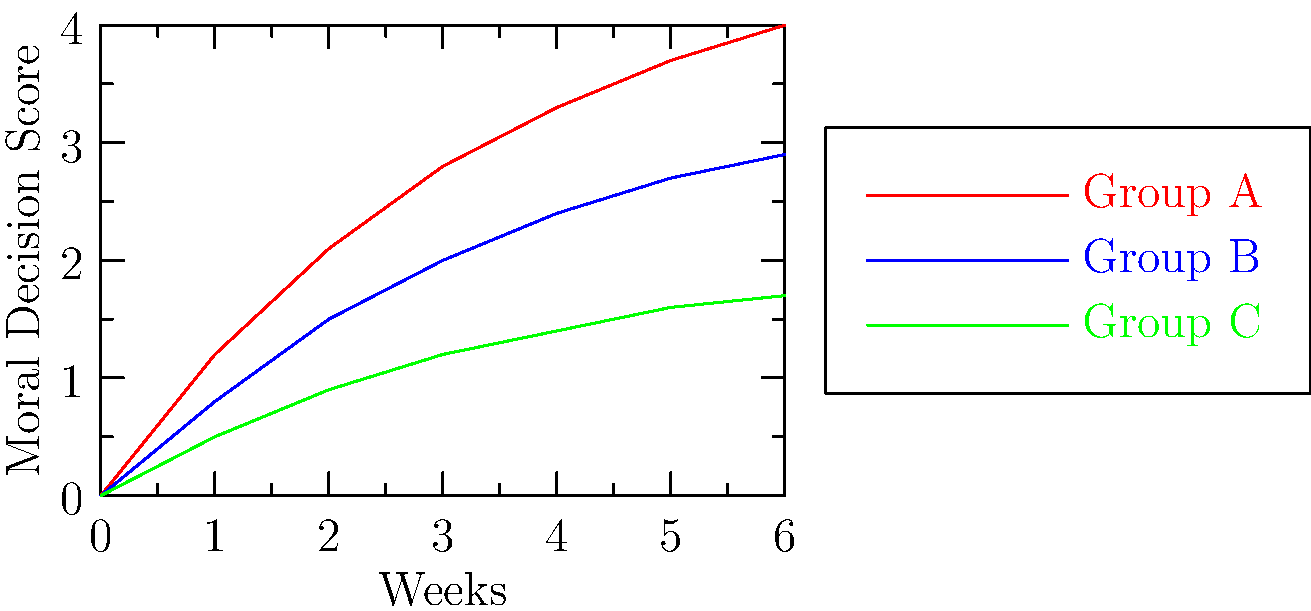A study was conducted to compare the effectiveness of three different moral education interventions in virtual environments. The graph shows the average moral decision scores for three groups over a 6-week period. Based on the data presented, which intervention appears to be the most effective in improving moral decision-making, and what is the approximate difference in scores between the most and least effective interventions at the end of the study? To answer this question, we need to analyze the graph and compare the three intervention groups:

1. Identify the groups:
   - Group A (red line)
   - Group B (blue line)
   - Group C (green line)

2. Compare the final scores at week 6:
   - Group A: approximately 4.0
   - Group B: approximately 2.9
   - Group C: approximately 1.7

3. Determine the most effective intervention:
   Group A has the highest final score, indicating it is the most effective intervention.

4. Determine the least effective intervention:
   Group C has the lowest final score, indicating it is the least effective intervention.

5. Calculate the approximate difference between the most and least effective interventions:
   Difference = Group A score - Group C score
               ≈ 4.0 - 1.7
               ≈ 2.3

Therefore, Group A's intervention appears to be the most effective in improving moral decision-making, and the approximate difference in scores between the most effective (Group A) and least effective (Group C) interventions at the end of the study is 2.3 points.
Answer: Group A; 2.3 points 